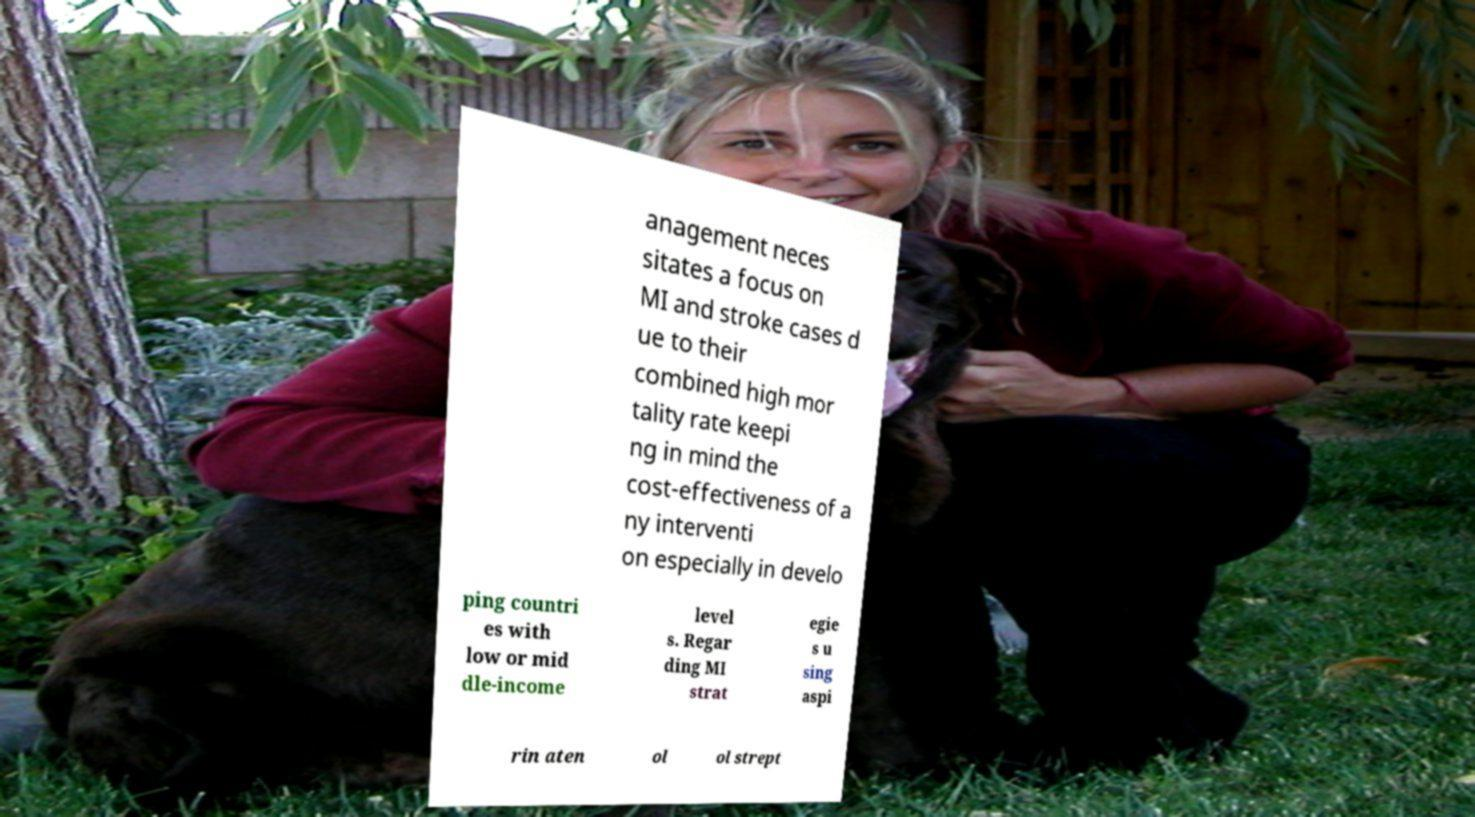Could you extract and type out the text from this image? anagement neces sitates a focus on MI and stroke cases d ue to their combined high mor tality rate keepi ng in mind the cost-effectiveness of a ny interventi on especially in develo ping countri es with low or mid dle-income level s. Regar ding MI strat egie s u sing aspi rin aten ol ol strept 